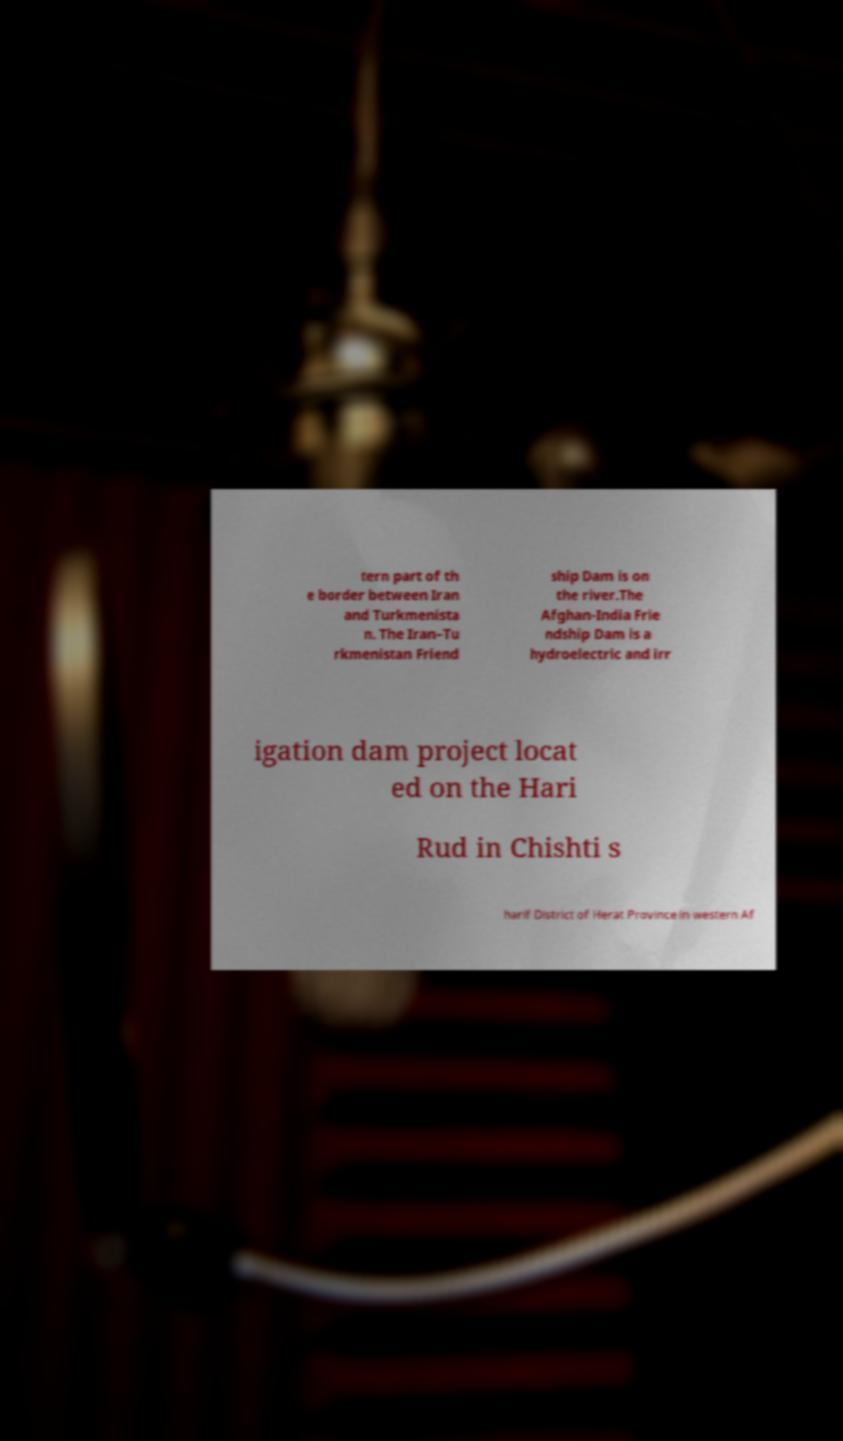Please identify and transcribe the text found in this image. tern part of th e border between Iran and Turkmenista n. The Iran–Tu rkmenistan Friend ship Dam is on the river.The Afghan-India Frie ndship Dam is a hydroelectric and irr igation dam project locat ed on the Hari Rud in Chishti s harif District of Herat Province in western Af 